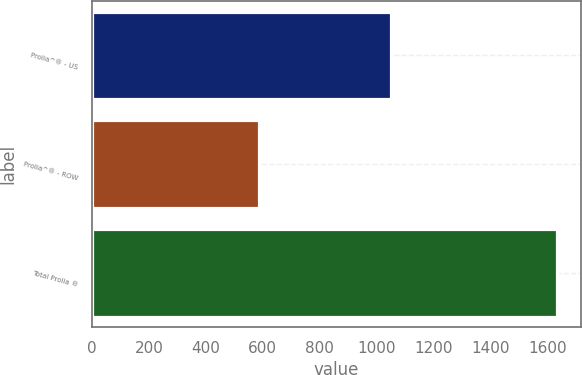Convert chart to OTSL. <chart><loc_0><loc_0><loc_500><loc_500><bar_chart><fcel>Prolia^® - US<fcel>Prolia^® - ROW<fcel>Total Prolia ®<nl><fcel>1049<fcel>586<fcel>1635<nl></chart> 